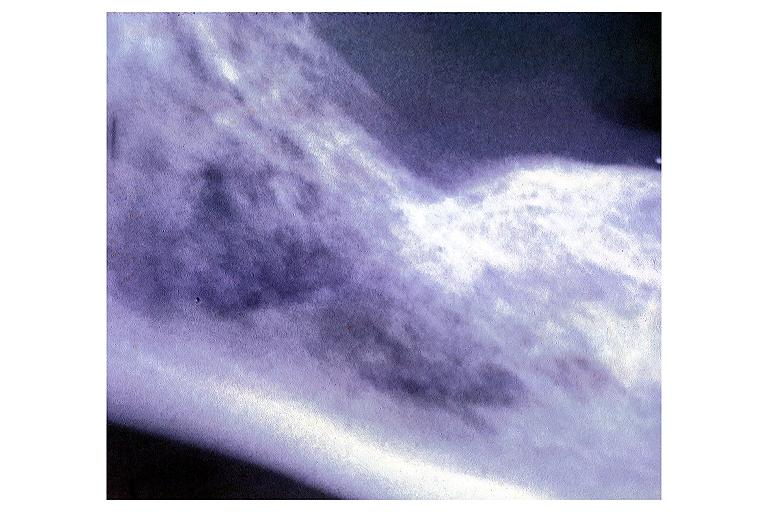does this image show metastatic adenocarcinoma?
Answer the question using a single word or phrase. Yes 